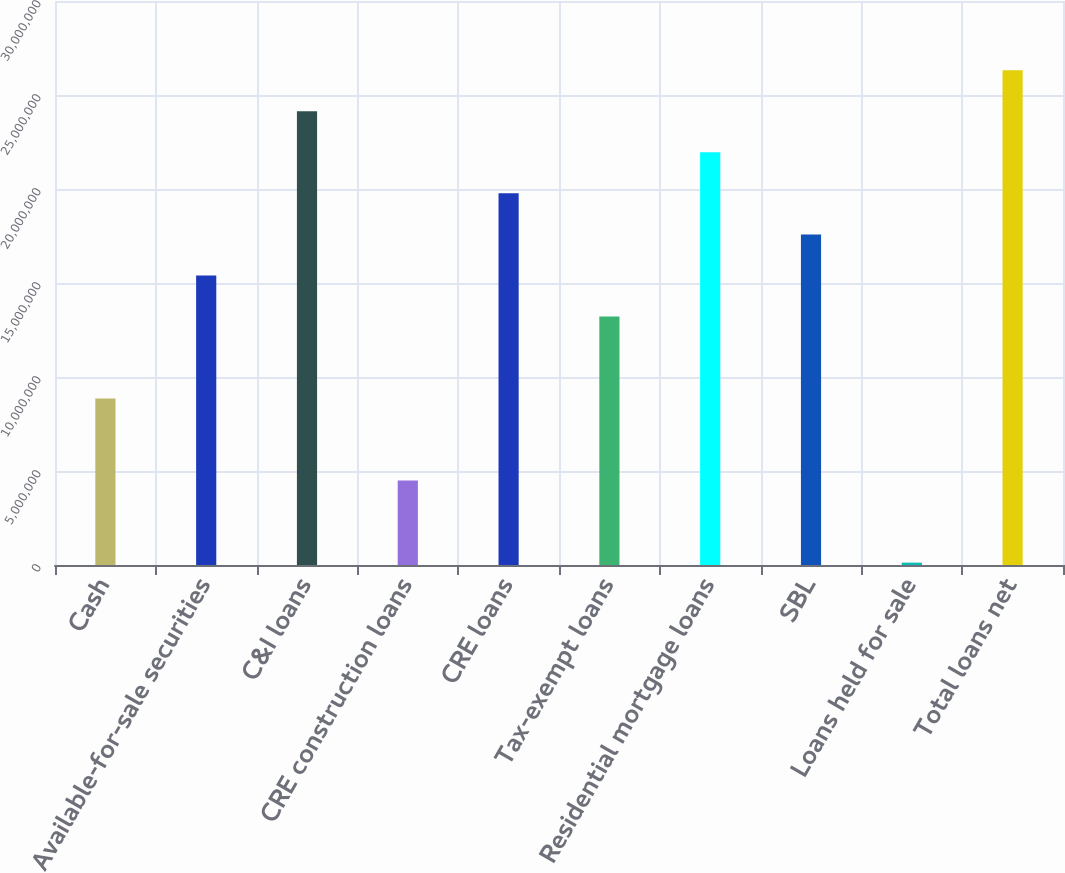Convert chart. <chart><loc_0><loc_0><loc_500><loc_500><bar_chart><fcel>Cash<fcel>Available-for-sale securities<fcel>C&I loans<fcel>CRE construction loans<fcel>CRE loans<fcel>Tax-exempt loans<fcel>Residential mortgage loans<fcel>SBL<fcel>Loans held for sale<fcel>Total loans net<nl><fcel>8.8559e+06<fcel>1.54034e+07<fcel>2.41333e+07<fcel>4.49094e+06<fcel>1.97683e+07<fcel>1.32209e+07<fcel>2.19508e+07<fcel>1.75858e+07<fcel>125970<fcel>2.63158e+07<nl></chart> 